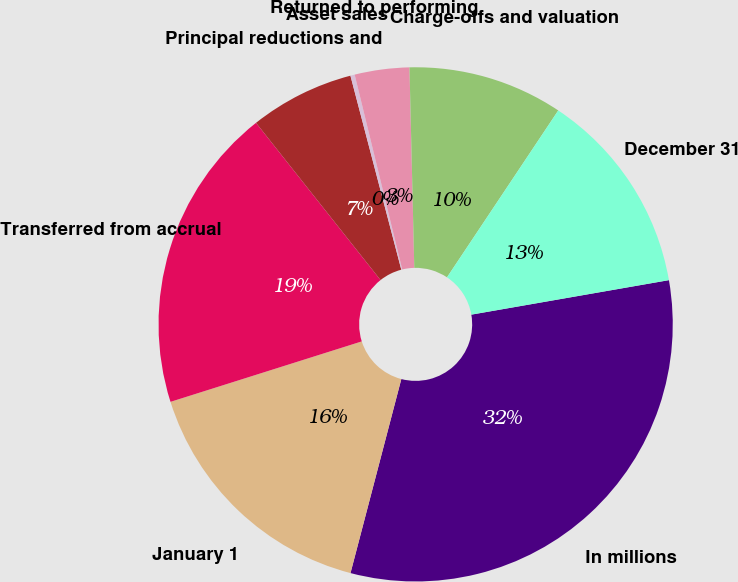<chart> <loc_0><loc_0><loc_500><loc_500><pie_chart><fcel>In millions<fcel>January 1<fcel>Transferred from accrual<fcel>Principal reductions and<fcel>Asset sales<fcel>Returned to performing<fcel>Charge-offs and valuation<fcel>December 31<nl><fcel>31.83%<fcel>16.05%<fcel>19.21%<fcel>6.58%<fcel>0.27%<fcel>3.43%<fcel>9.74%<fcel>12.89%<nl></chart> 